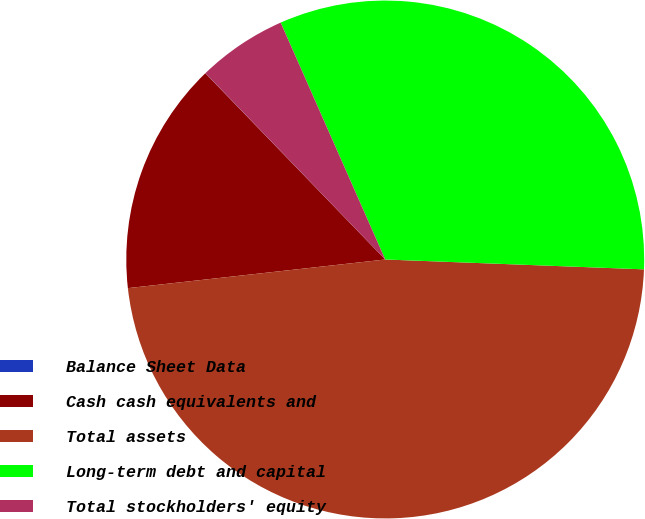Convert chart. <chart><loc_0><loc_0><loc_500><loc_500><pie_chart><fcel>Balance Sheet Data<fcel>Cash cash equivalents and<fcel>Total assets<fcel>Long-term debt and capital<fcel>Total stockholders' equity<nl><fcel>0.01%<fcel>14.54%<fcel>47.63%<fcel>32.22%<fcel>5.6%<nl></chart> 